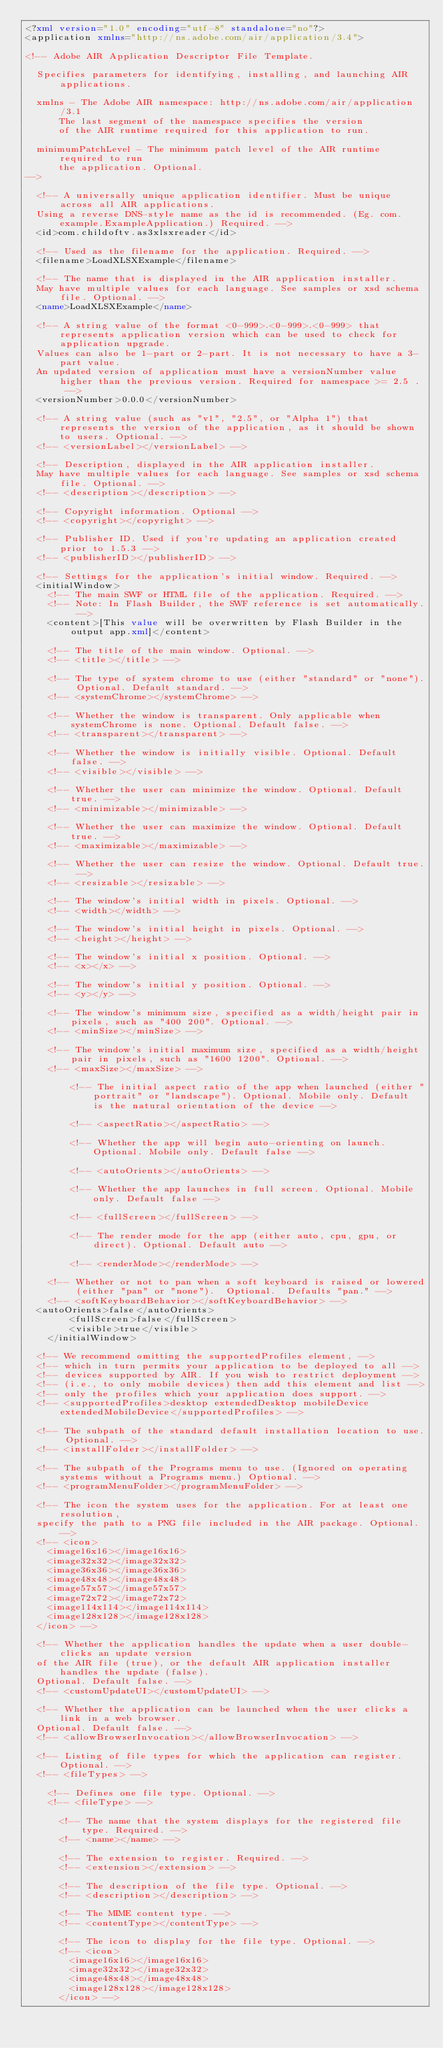<code> <loc_0><loc_0><loc_500><loc_500><_XML_><?xml version="1.0" encoding="utf-8" standalone="no"?>
<application xmlns="http://ns.adobe.com/air/application/3.4">

<!-- Adobe AIR Application Descriptor File Template.

	Specifies parameters for identifying, installing, and launching AIR applications.

	xmlns - The Adobe AIR namespace: http://ns.adobe.com/air/application/3.1
			The last segment of the namespace specifies the version 
			of the AIR runtime required for this application to run.
			
	minimumPatchLevel - The minimum patch level of the AIR runtime required to run 
			the application. Optional.
-->

	<!-- A universally unique application identifier. Must be unique across all AIR applications.
	Using a reverse DNS-style name as the id is recommended. (Eg. com.example.ExampleApplication.) Required. -->
	<id>com.childoftv.as3xlsxreader</id>

	<!-- Used as the filename for the application. Required. -->
	<filename>LoadXLSXExample</filename>

	<!-- The name that is displayed in the AIR application installer. 
	May have multiple values for each language. See samples or xsd schema file. Optional. -->
	<name>LoadXLSXExample</name>
	
	<!-- A string value of the format <0-999>.<0-999>.<0-999> that represents application version which can be used to check for application upgrade. 
	Values can also be 1-part or 2-part. It is not necessary to have a 3-part value.
	An updated version of application must have a versionNumber value higher than the previous version. Required for namespace >= 2.5 . -->
	<versionNumber>0.0.0</versionNumber>
		         
	<!-- A string value (such as "v1", "2.5", or "Alpha 1") that represents the version of the application, as it should be shown to users. Optional. -->
	<!-- <versionLabel></versionLabel> -->

	<!-- Description, displayed in the AIR application installer.
	May have multiple values for each language. See samples or xsd schema file. Optional. -->
	<!-- <description></description> -->

	<!-- Copyright information. Optional -->
	<!-- <copyright></copyright> -->

	<!-- Publisher ID. Used if you're updating an application created prior to 1.5.3 -->
	<!-- <publisherID></publisherID> -->

	<!-- Settings for the application's initial window. Required. -->
	<initialWindow>
		<!-- The main SWF or HTML file of the application. Required. -->
		<!-- Note: In Flash Builder, the SWF reference is set automatically. -->
		<content>[This value will be overwritten by Flash Builder in the output app.xml]</content>
		
		<!-- The title of the main window. Optional. -->
		<!-- <title></title> -->

		<!-- The type of system chrome to use (either "standard" or "none"). Optional. Default standard. -->
		<!-- <systemChrome></systemChrome> -->

		<!-- Whether the window is transparent. Only applicable when systemChrome is none. Optional. Default false. -->
		<!-- <transparent></transparent> -->

		<!-- Whether the window is initially visible. Optional. Default false. -->
		<!-- <visible></visible> -->

		<!-- Whether the user can minimize the window. Optional. Default true. -->
		<!-- <minimizable></minimizable> -->

		<!-- Whether the user can maximize the window. Optional. Default true. -->
		<!-- <maximizable></maximizable> -->

		<!-- Whether the user can resize the window. Optional. Default true. -->
		<!-- <resizable></resizable> -->

		<!-- The window's initial width in pixels. Optional. -->
		<!-- <width></width> -->

		<!-- The window's initial height in pixels. Optional. -->
		<!-- <height></height> -->

		<!-- The window's initial x position. Optional. -->
		<!-- <x></x> -->

		<!-- The window's initial y position. Optional. -->
		<!-- <y></y> -->

		<!-- The window's minimum size, specified as a width/height pair in pixels, such as "400 200". Optional. -->
		<!-- <minSize></minSize> -->

		<!-- The window's initial maximum size, specified as a width/height pair in pixels, such as "1600 1200". Optional. -->
		<!-- <maxSize></maxSize> -->

        <!-- The initial aspect ratio of the app when launched (either "portrait" or "landscape"). Optional. Mobile only. Default is the natural orientation of the device -->

        <!-- <aspectRatio></aspectRatio> -->

        <!-- Whether the app will begin auto-orienting on launch. Optional. Mobile only. Default false -->

        <!-- <autoOrients></autoOrients> -->

        <!-- Whether the app launches in full screen. Optional. Mobile only. Default false -->

        <!-- <fullScreen></fullScreen> -->

        <!-- The render mode for the app (either auto, cpu, gpu, or direct). Optional. Default auto -->

        <!-- <renderMode></renderMode> -->

		<!-- Whether or not to pan when a soft keyboard is raised or lowered (either "pan" or "none").  Optional.  Defaults "pan." -->
		<!-- <softKeyboardBehavior></softKeyboardBehavior> -->
	<autoOrients>false</autoOrients>
        <fullScreen>false</fullScreen>
        <visible>true</visible>
    </initialWindow>

	<!-- We recommend omitting the supportedProfiles element, -->
	<!-- which in turn permits your application to be deployed to all -->
	<!-- devices supported by AIR. If you wish to restrict deployment -->
	<!-- (i.e., to only mobile devices) then add this element and list -->
	<!-- only the profiles which your application does support. -->
	<!-- <supportedProfiles>desktop extendedDesktop mobileDevice extendedMobileDevice</supportedProfiles> -->

	<!-- The subpath of the standard default installation location to use. Optional. -->
	<!-- <installFolder></installFolder> -->

	<!-- The subpath of the Programs menu to use. (Ignored on operating systems without a Programs menu.) Optional. -->
	<!-- <programMenuFolder></programMenuFolder> -->

	<!-- The icon the system uses for the application. For at least one resolution,
	specify the path to a PNG file included in the AIR package. Optional. -->
	<!-- <icon>
		<image16x16></image16x16>
		<image32x32></image32x32>
		<image36x36></image36x36>
		<image48x48></image48x48>
		<image57x57></image57x57>
		<image72x72></image72x72>
		<image114x114></image114x114>
		<image128x128></image128x128>
	</icon> -->

	<!-- Whether the application handles the update when a user double-clicks an update version
	of the AIR file (true), or the default AIR application installer handles the update (false).
	Optional. Default false. -->
	<!-- <customUpdateUI></customUpdateUI> -->
	
	<!-- Whether the application can be launched when the user clicks a link in a web browser.
	Optional. Default false. -->
	<!-- <allowBrowserInvocation></allowBrowserInvocation> -->

	<!-- Listing of file types for which the application can register. Optional. -->
	<!-- <fileTypes> -->

		<!-- Defines one file type. Optional. -->
		<!-- <fileType> -->

			<!-- The name that the system displays for the registered file type. Required. -->
			<!-- <name></name> -->

			<!-- The extension to register. Required. -->
			<!-- <extension></extension> -->
			
			<!-- The description of the file type. Optional. -->
			<!-- <description></description> -->
			
			<!-- The MIME content type. -->
			<!-- <contentType></contentType> -->
			
			<!-- The icon to display for the file type. Optional. -->
			<!-- <icon>
				<image16x16></image16x16>
				<image32x32></image32x32>
				<image48x48></image48x48>
				<image128x128></image128x128>
			</icon> -->
			</code> 